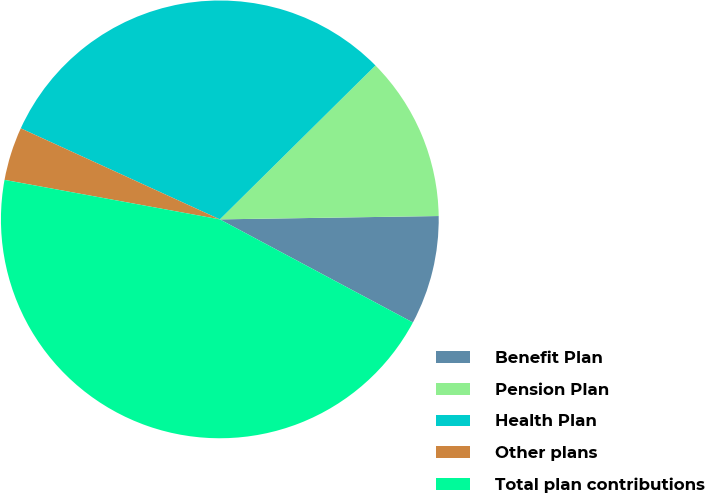Convert chart to OTSL. <chart><loc_0><loc_0><loc_500><loc_500><pie_chart><fcel>Benefit Plan<fcel>Pension Plan<fcel>Health Plan<fcel>Other plans<fcel>Total plan contributions<nl><fcel>8.05%<fcel>12.17%<fcel>30.76%<fcel>3.94%<fcel>45.08%<nl></chart> 